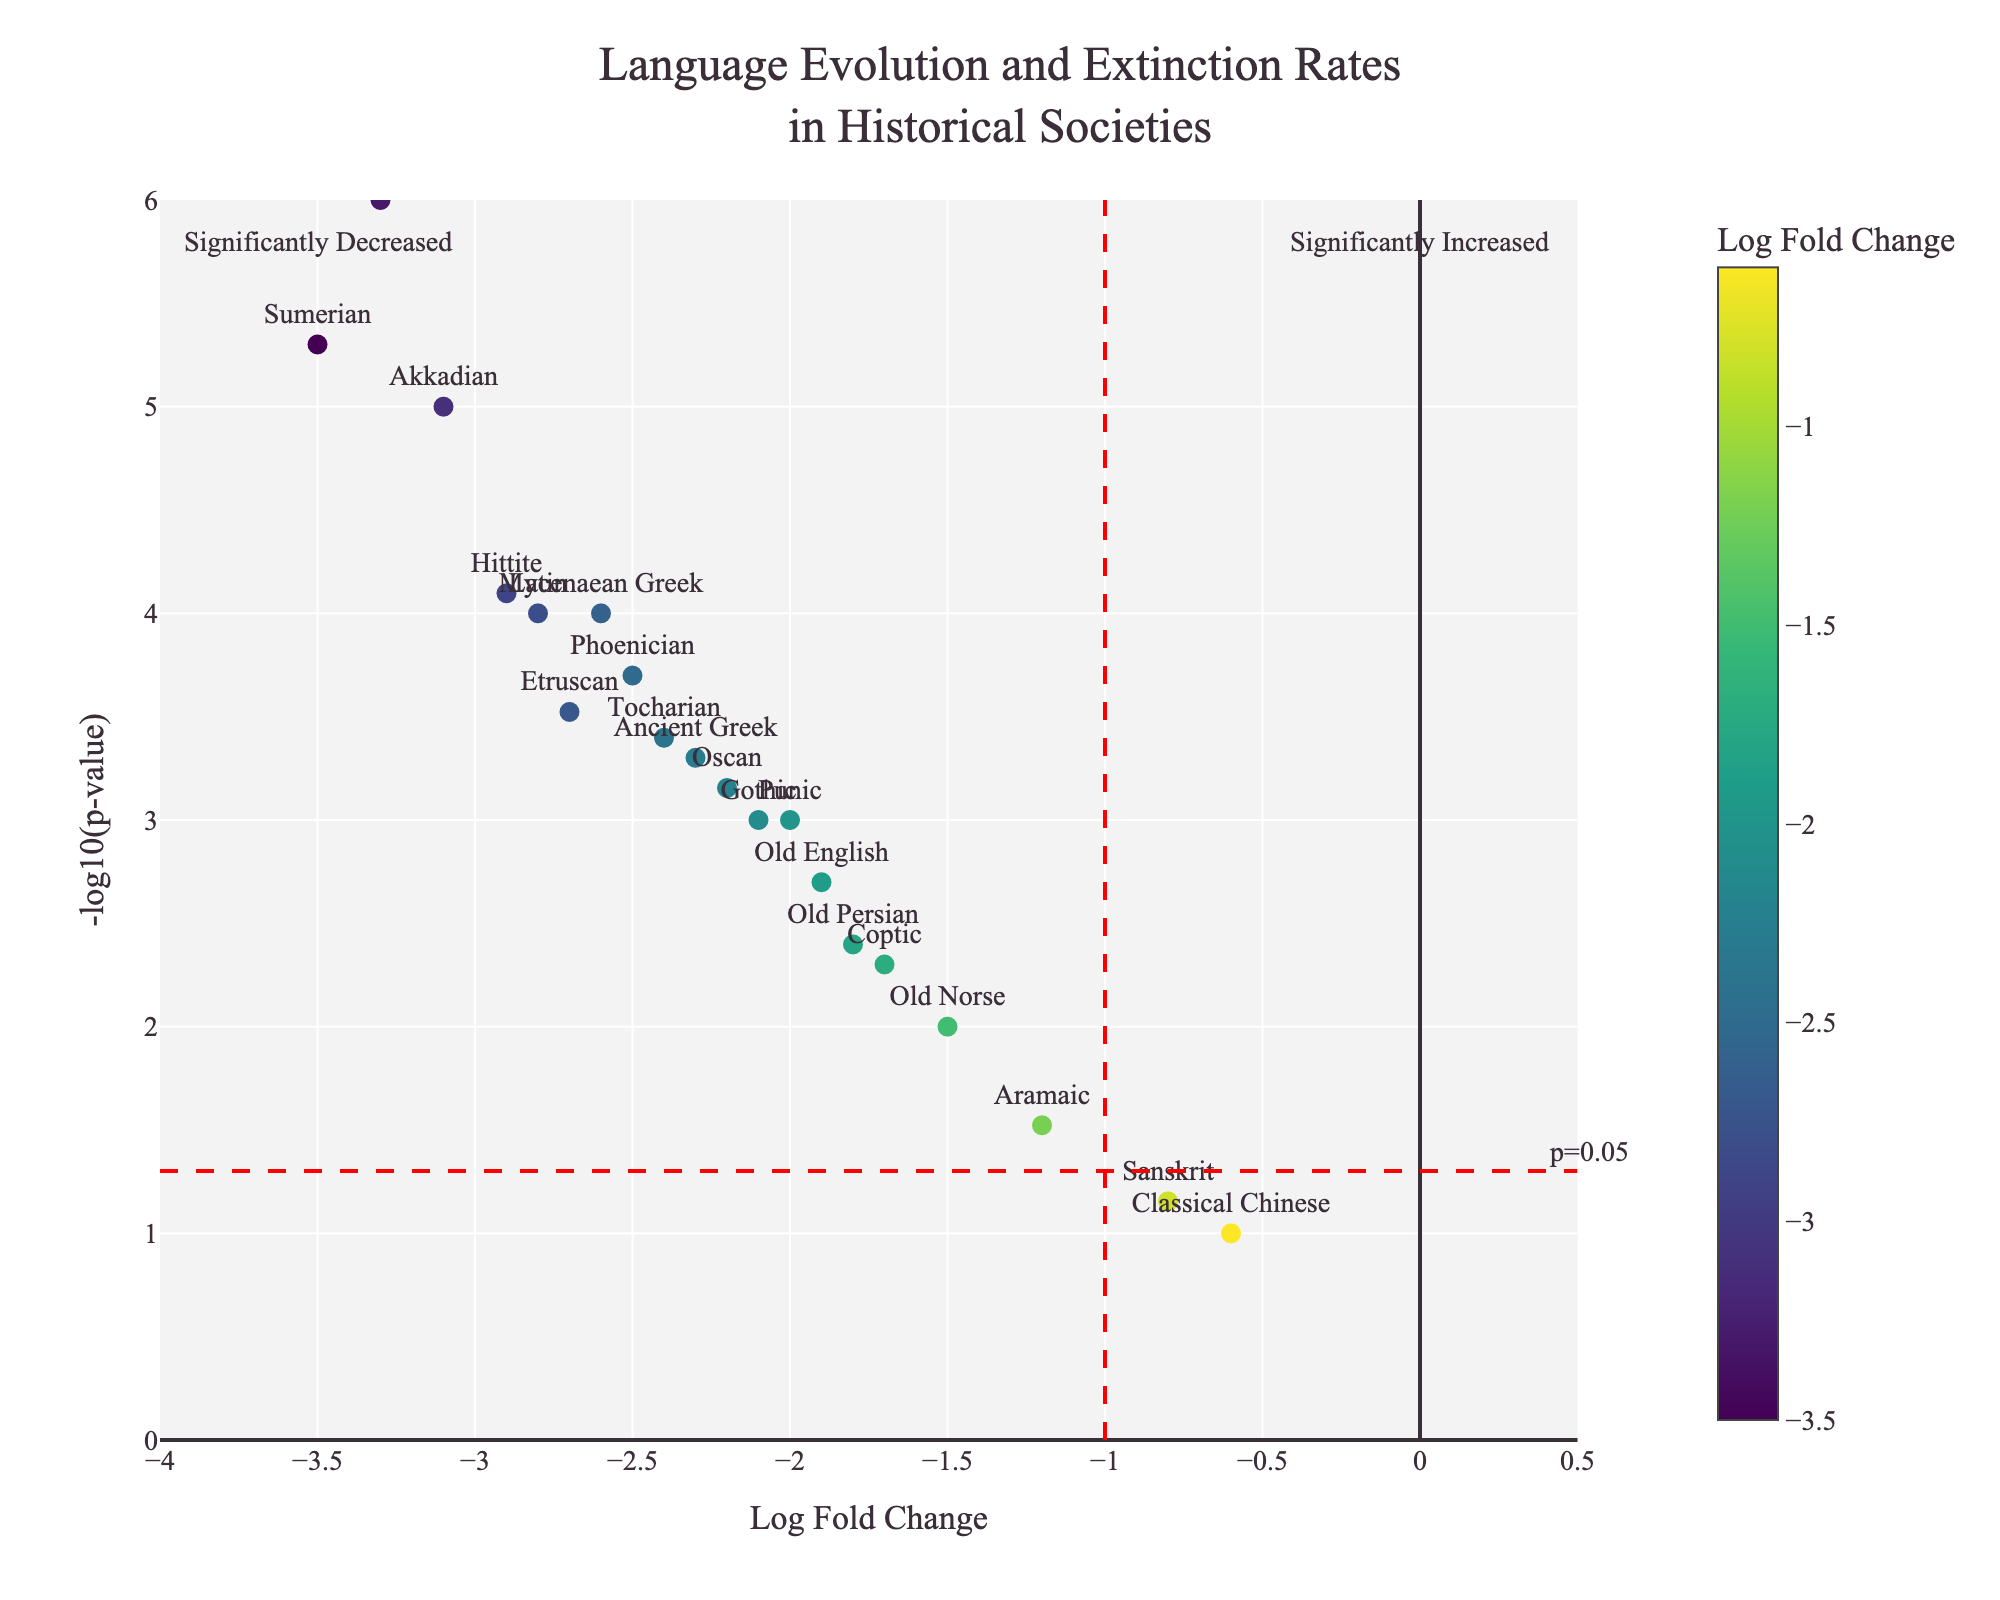What's the title of the figure? The title is usually located at the top center of the figure. It provides a concise description of the content being visualized. In this case, the title reads "Language Evolution and Extinction Rates in Historical Societies".
Answer: Language Evolution and Extinction Rates in Historical Societies How can you interpret the y-axis label? The y-axis label "-log10(p-value)" indicates that the y-axis represents the negative logarithm base 10 of the p-values. High values on this axis correspond to low p-values, indicating high statistical significance.
Answer: -log10(p-value) How many languages are represented in the plot? To determine this, count the distinct points plotted on the figure, each representing a different language. In this case, there are 20 languages listed in the data.
Answer: 20 Which language has the smallest log fold change? Locate the point with the lowest value on the x-axis, which represents the log fold change. The lowest log fold change is -3.5, associated with the Sumerian language.
Answer: Sumerian Which language has the highest statistical significance (smallest p-value)? The highest statistical significance corresponds to the lowest p-value, which translates into the highest -log10(p-value). This is marked by the point at the topmost position on the y-axis. Linear A has the highest statistical significance with a p-value of 0.000001, corresponding to a -log10(p-value) of 6.
Answer: Linear A What color represents languages with higher log fold changes? In the volcanic plot, the colors are determined by a color scale where the value of the log fold change affects the color. Higher log fold changes are typically represented by a different hue. The figure uses a Viridis color scale where higher log fold changes are generally depicted in darker green shades.
Answer: Darker green shades How many languages have a p-value less than 0.05? A p-value of 0.05 corresponds to a -log10(p-value) of about 1.3. Count the points that are above the horizontal threshold line at y = 1.3. In this figure, there are 14 points above the line, indicating these languages have p-values less than 0.05.
Answer: 14 Which language has a log fold change closest to -2.5? Identify the language point nearest to x = -2.5. By examining the data near that value, Phoenician has a log fold change very close to -2.5.
Answer: Phoenician Are there more languages with significant increases or decreases in the plot? The plot is divided into significantly increased and decreased areas by vertical lines at a log fold change of ±1. Count the points in each area. Since all log fold changes are negative, there are no significant increases and only significant decreases.
Answer: Significant decreases 